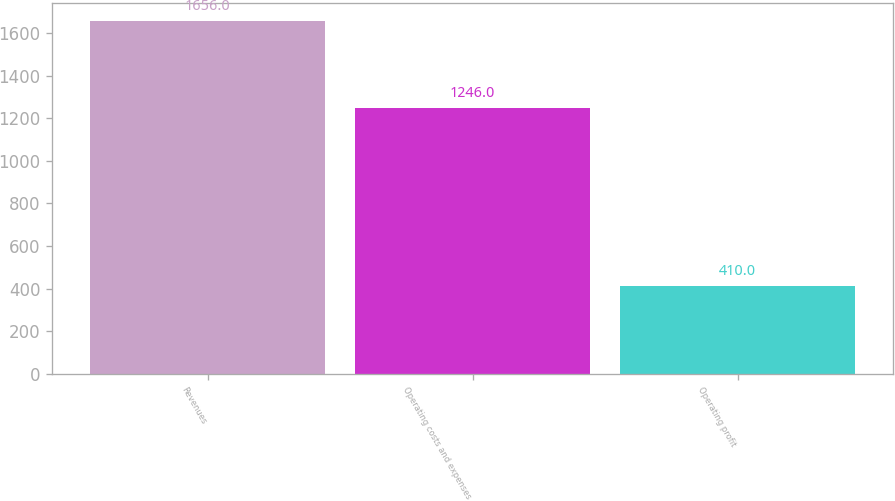Convert chart to OTSL. <chart><loc_0><loc_0><loc_500><loc_500><bar_chart><fcel>Revenues<fcel>Operating costs and expenses<fcel>Operating profit<nl><fcel>1656<fcel>1246<fcel>410<nl></chart> 